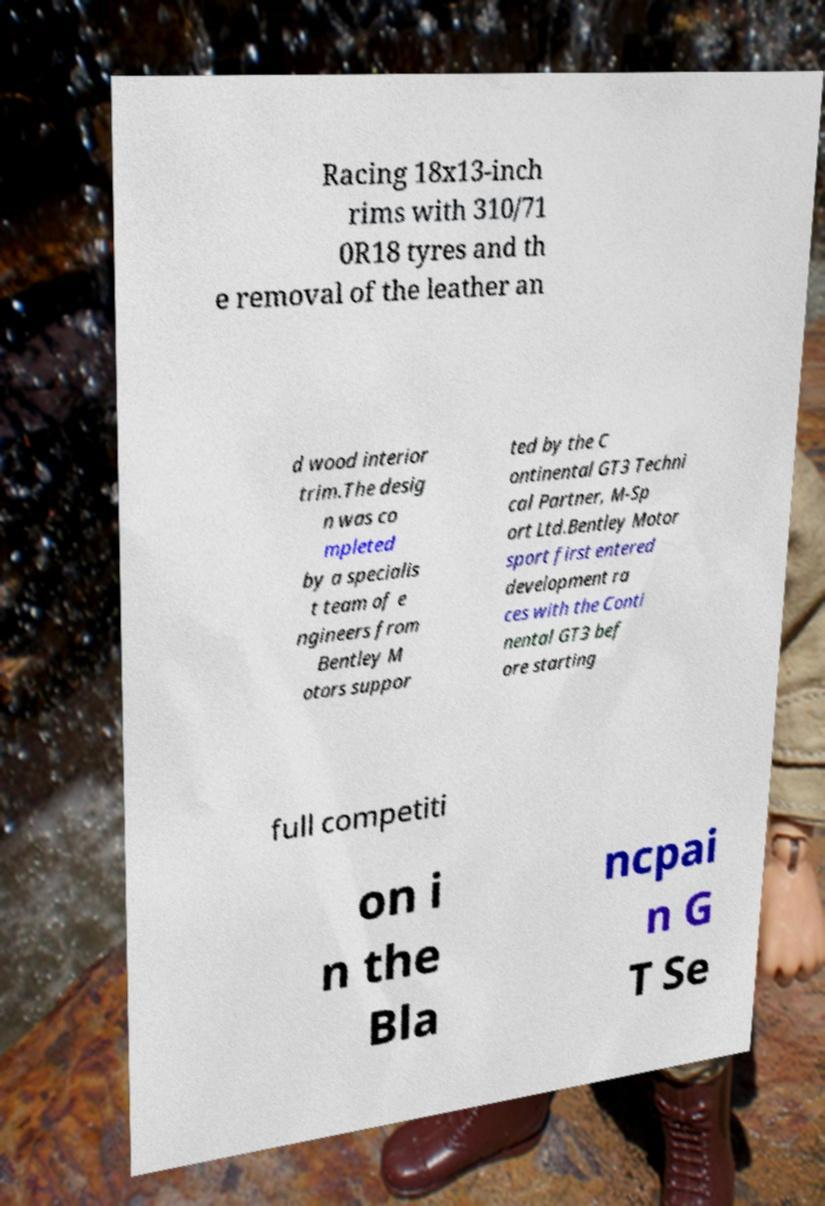Could you assist in decoding the text presented in this image and type it out clearly? Racing 18x13-inch rims with 310/71 0R18 tyres and th e removal of the leather an d wood interior trim.The desig n was co mpleted by a specialis t team of e ngineers from Bentley M otors suppor ted by the C ontinental GT3 Techni cal Partner, M-Sp ort Ltd.Bentley Motor sport first entered development ra ces with the Conti nental GT3 bef ore starting full competiti on i n the Bla ncpai n G T Se 